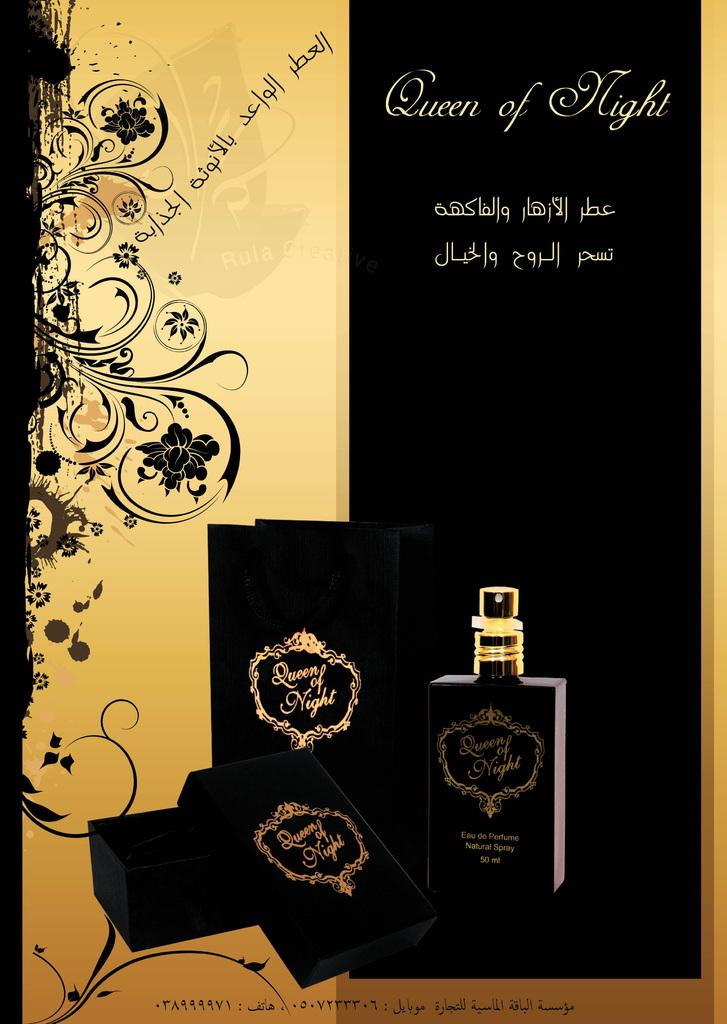<image>
Describe the image concisely. A black and gold advertisement is promoting Queen of Night perfume. 